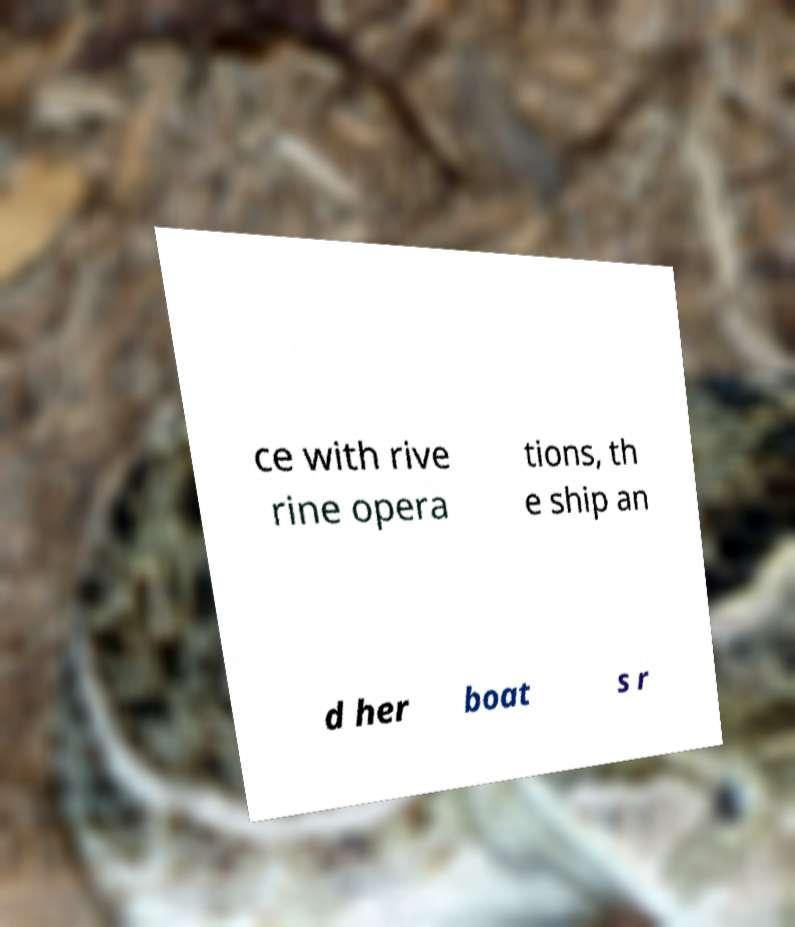Could you assist in decoding the text presented in this image and type it out clearly? ce with rive rine opera tions, th e ship an d her boat s r 